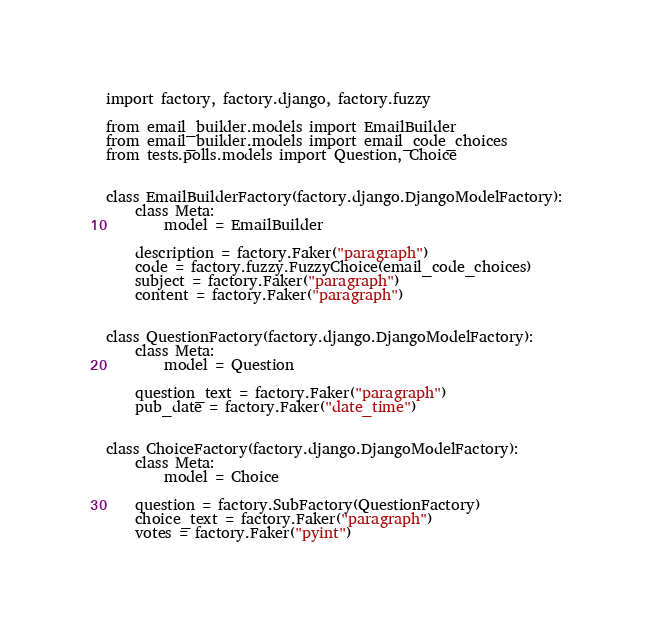<code> <loc_0><loc_0><loc_500><loc_500><_Python_>import factory, factory.django, factory.fuzzy

from email_builder.models import EmailBuilder
from email_builder.models import email_code_choices
from tests.polls.models import Question, Choice


class EmailBuilderFactory(factory.django.DjangoModelFactory):
    class Meta:
        model = EmailBuilder

    description = factory.Faker("paragraph")
    code = factory.fuzzy.FuzzyChoice(email_code_choices)
    subject = factory.Faker("paragraph")
    content = factory.Faker("paragraph")


class QuestionFactory(factory.django.DjangoModelFactory):
    class Meta:
        model = Question

    question_text = factory.Faker("paragraph")
    pub_date = factory.Faker("date_time")


class ChoiceFactory(factory.django.DjangoModelFactory):
    class Meta:
        model = Choice

    question = factory.SubFactory(QuestionFactory)
    choice_text = factory.Faker("paragraph")
    votes = factory.Faker("pyint")


</code> 